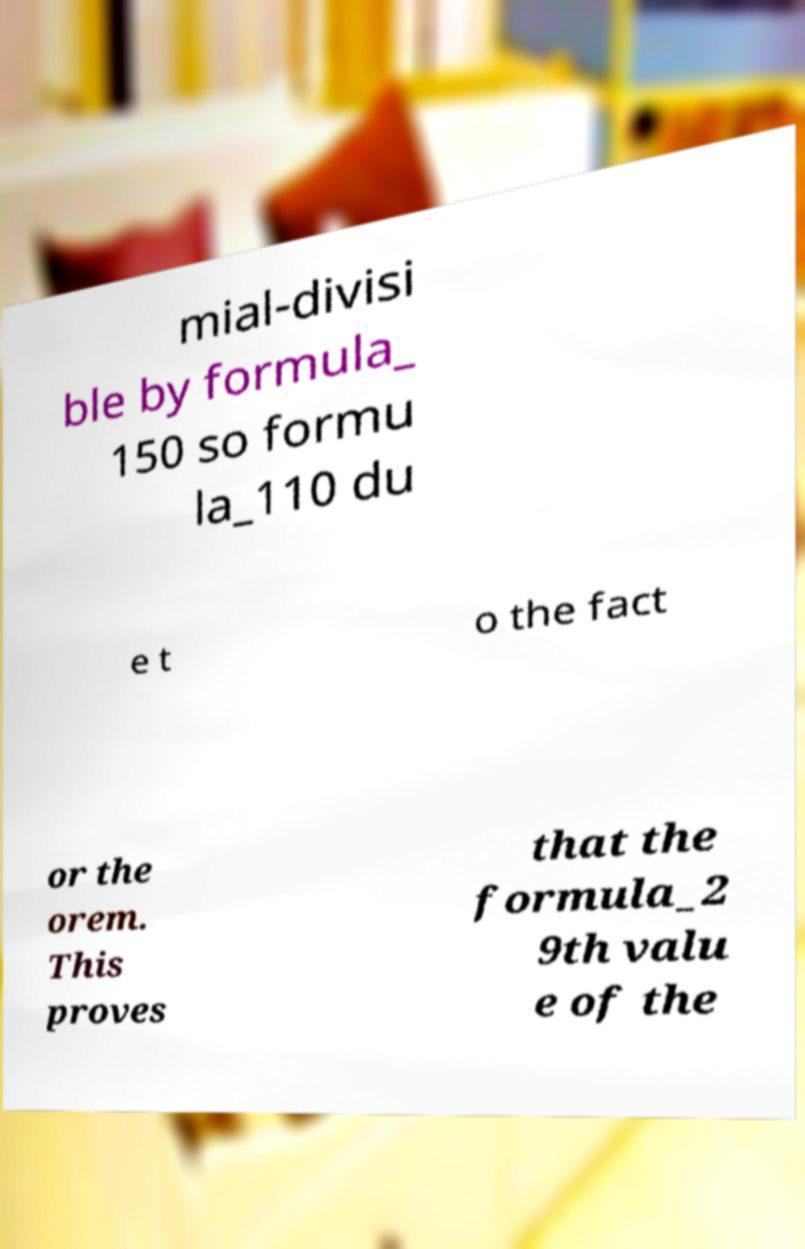What messages or text are displayed in this image? I need them in a readable, typed format. mial-divisi ble by formula_ 150 so formu la_110 du e t o the fact or the orem. This proves that the formula_2 9th valu e of the 